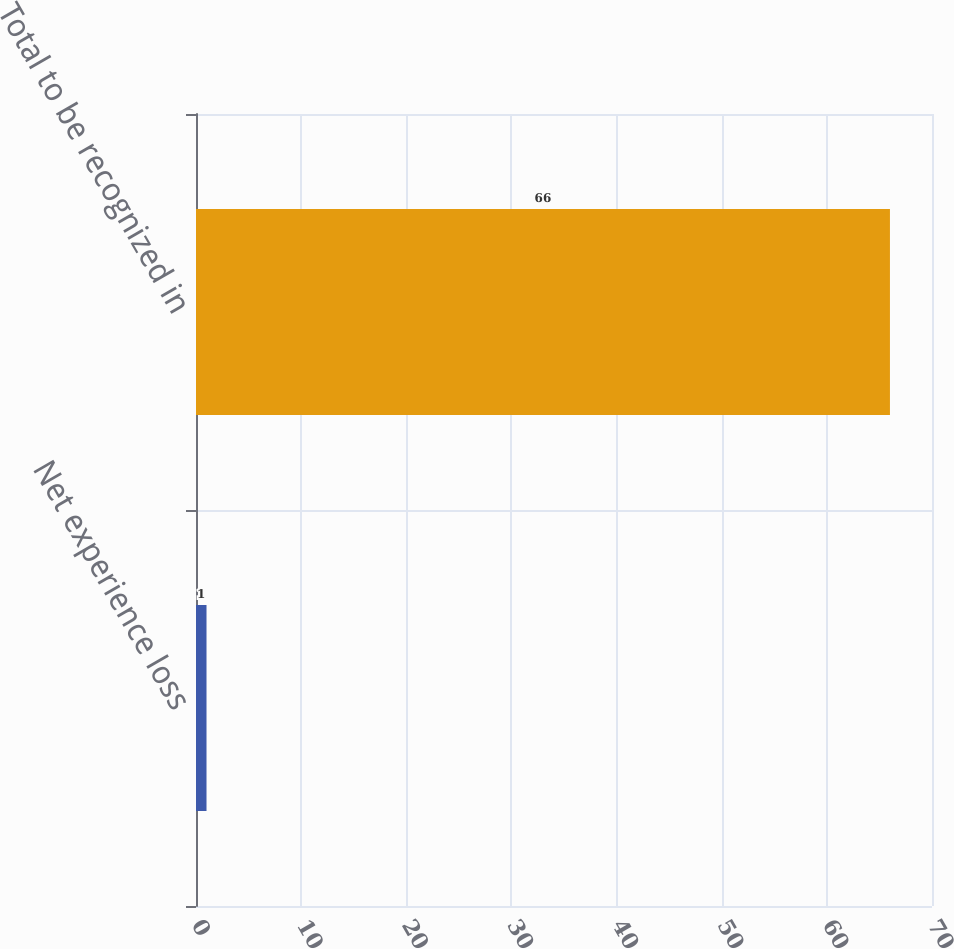Convert chart. <chart><loc_0><loc_0><loc_500><loc_500><bar_chart><fcel>Net experience loss<fcel>Total to be recognized in<nl><fcel>1<fcel>66<nl></chart> 